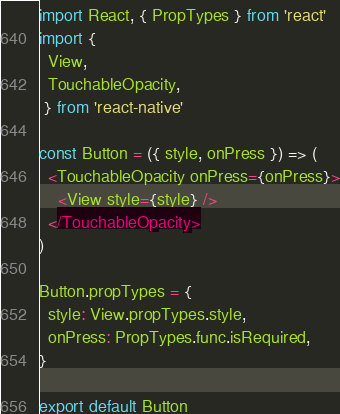<code> <loc_0><loc_0><loc_500><loc_500><_JavaScript_>import React, { PropTypes } from 'react'
import {
  View,
  TouchableOpacity,
 } from 'react-native'

const Button = ({ style, onPress }) => (
  <TouchableOpacity onPress={onPress}>
    <View style={style} />
  </TouchableOpacity>
)

Button.propTypes = {
  style: View.propTypes.style,
  onPress: PropTypes.func.isRequired,
}

export default Button
</code> 